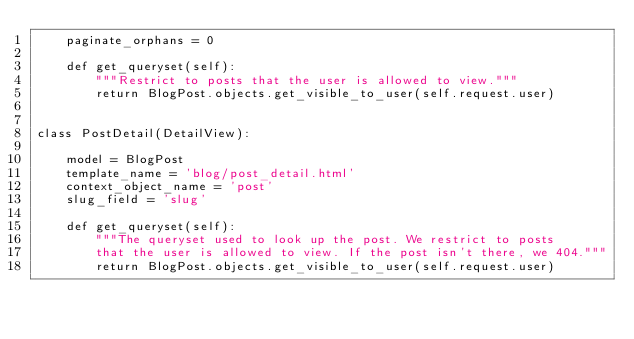Convert code to text. <code><loc_0><loc_0><loc_500><loc_500><_Python_>    paginate_orphans = 0

    def get_queryset(self):
        """Restrict to posts that the user is allowed to view."""
        return BlogPost.objects.get_visible_to_user(self.request.user)


class PostDetail(DetailView):

    model = BlogPost
    template_name = 'blog/post_detail.html'
    context_object_name = 'post'
    slug_field = 'slug'

    def get_queryset(self):
        """The queryset used to look up the post. We restrict to posts
        that the user is allowed to view. If the post isn't there, we 404."""
        return BlogPost.objects.get_visible_to_user(self.request.user)
</code> 